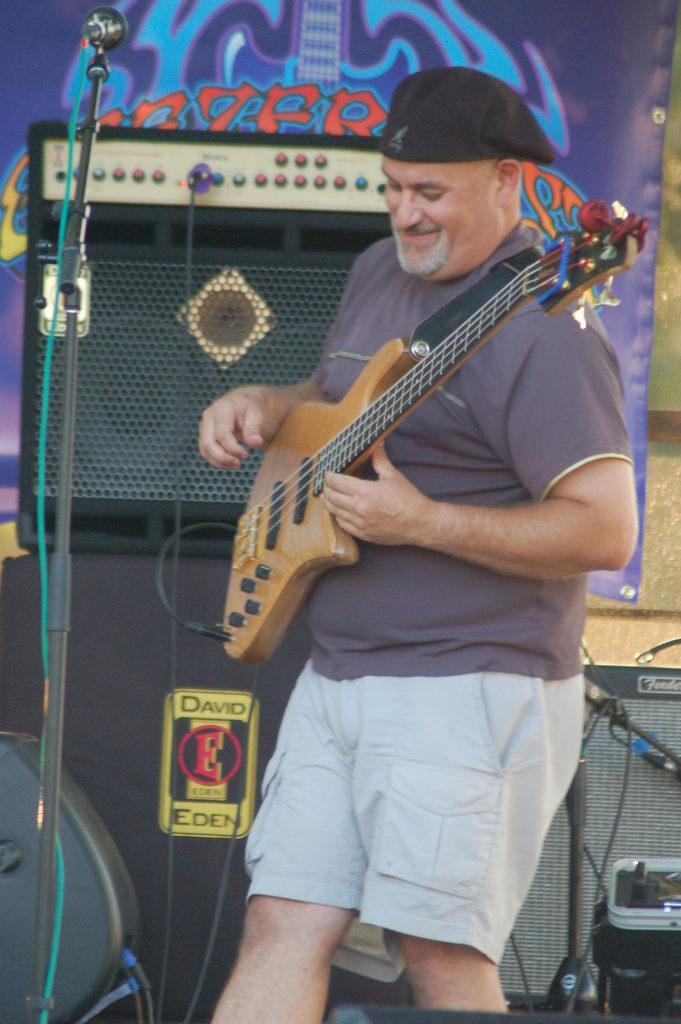Please provide a concise description of this image. In this image i can see a man is playing a guitar in front of a microphone. 